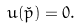Convert formula to latex. <formula><loc_0><loc_0><loc_500><loc_500>u ( \check { p } ) = 0 .</formula> 